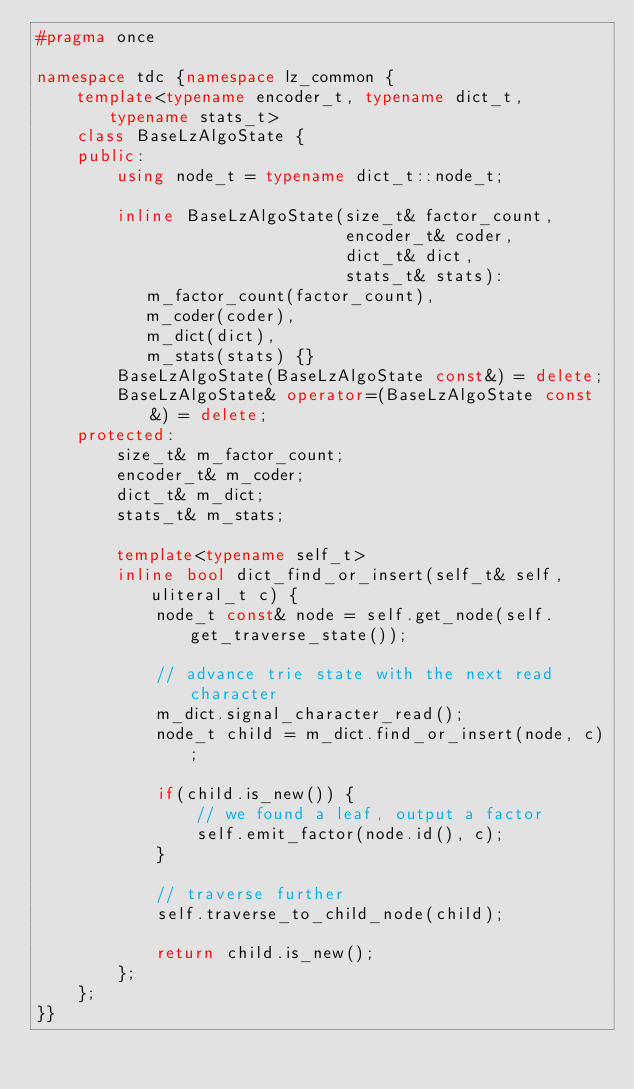Convert code to text. <code><loc_0><loc_0><loc_500><loc_500><_C++_>#pragma once

namespace tdc {namespace lz_common {
    template<typename encoder_t, typename dict_t, typename stats_t>
    class BaseLzAlgoState {
    public:
        using node_t = typename dict_t::node_t;

        inline BaseLzAlgoState(size_t& factor_count,
                               encoder_t& coder,
                               dict_t& dict,
                               stats_t& stats):
           m_factor_count(factor_count),
           m_coder(coder),
           m_dict(dict),
           m_stats(stats) {}
        BaseLzAlgoState(BaseLzAlgoState const&) = delete;
        BaseLzAlgoState& operator=(BaseLzAlgoState const&) = delete;
    protected:
        size_t& m_factor_count;
        encoder_t& m_coder;
        dict_t& m_dict;
        stats_t& m_stats;

        template<typename self_t>
        inline bool dict_find_or_insert(self_t& self, uliteral_t c) {
            node_t const& node = self.get_node(self.get_traverse_state());

            // advance trie state with the next read character
            m_dict.signal_character_read();
            node_t child = m_dict.find_or_insert(node, c);

            if(child.is_new()) {
                // we found a leaf, output a factor
                self.emit_factor(node.id(), c);
            }

            // traverse further
            self.traverse_to_child_node(child);

            return child.is_new();
        };
    };
}}
</code> 